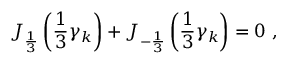Convert formula to latex. <formula><loc_0><loc_0><loc_500><loc_500>J _ { \frac { 1 } { 3 } } \left ( \frac { 1 } { 3 } \gamma _ { k } \right ) + J _ { - \frac { 1 } { 3 } } \left ( \frac { 1 } { 3 } \gamma _ { k } \right ) = 0 \, ,</formula> 